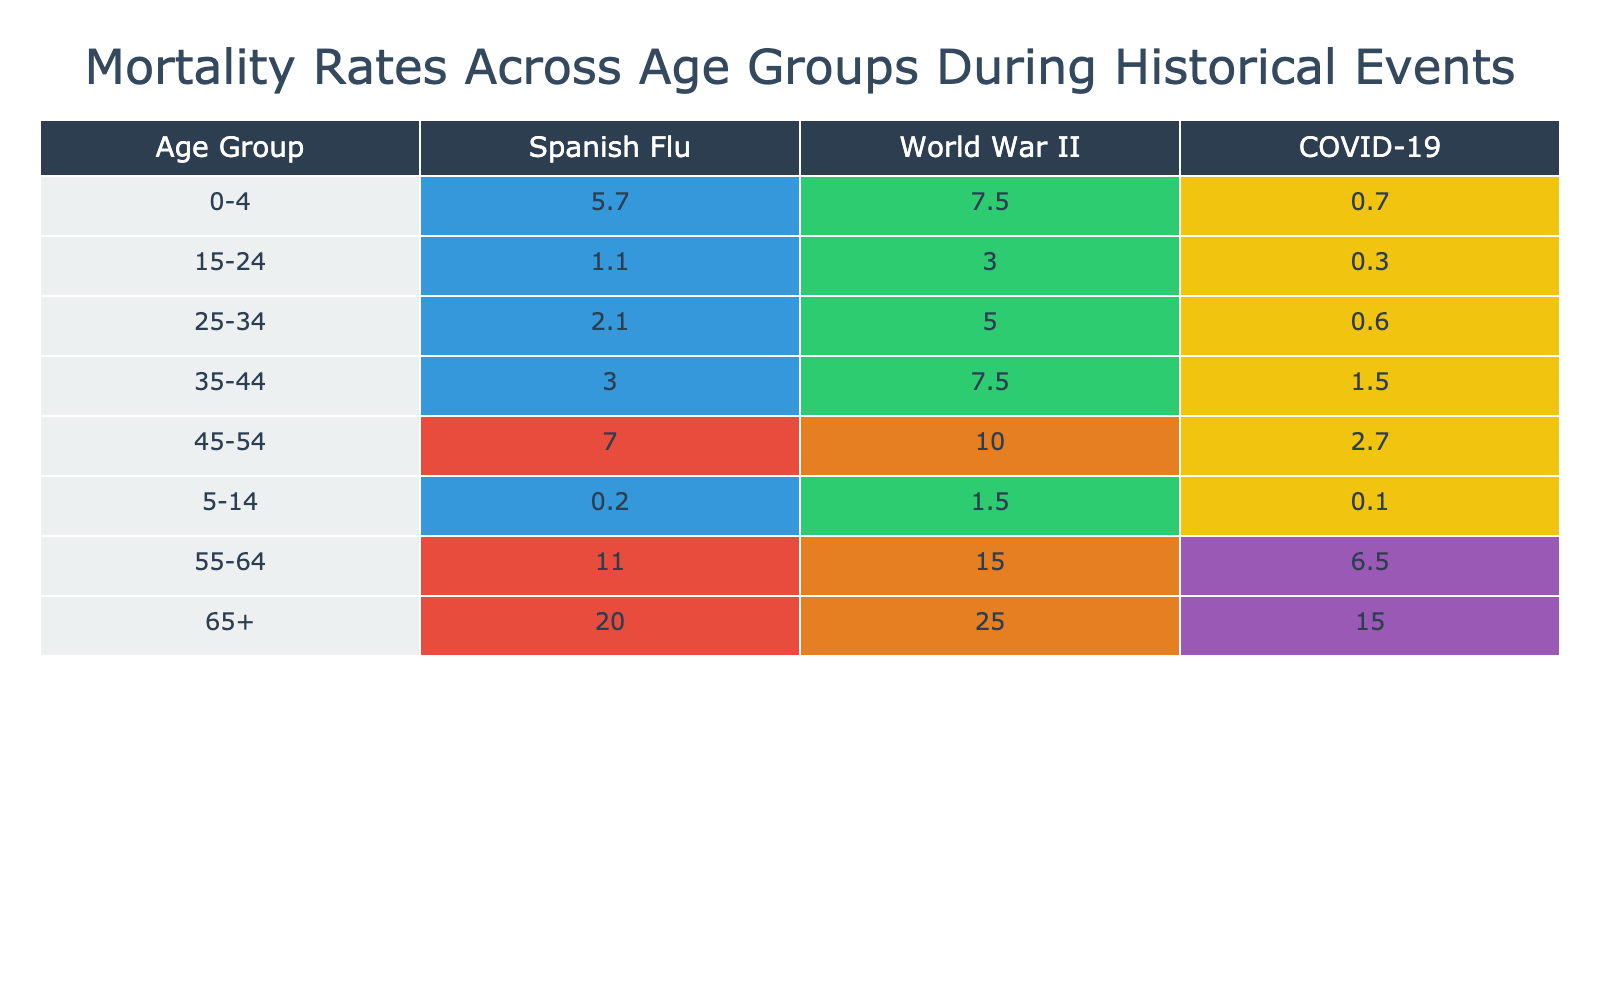What is the mortality rate for infants aged 0-4 during the Spanish Flu? According to the table, the mortality rate for the age group 0-4 during the event of the Spanish Flu in 1918 is listed as 5.7%.
Answer: 5.7% Which age group had the highest mortality rate during World War II? By examining the table, the age group 65+ during World War II (1939-1945) shows the highest mortality rate of 25.0%.
Answer: 65+ What is the difference in mortality rates between the age group 55-64 during the Spanish Flu and World War II? For the age group 55-64, the mortality rate during the Spanish Flu is 11.0% and during World War II, it is 15.0%. The difference is calculated as 15.0% - 11.0% = 4.0%.
Answer: 4.0% Was the mortality rate for children aged 5-14 higher during the Spanish Flu or World War II? The mortality rate for the age group 5-14 during the Spanish Flu is 0.2% and during World War II, it is 1.5%. Since 1.5% is greater than 0.2%, the mortality rate was higher during World War II.
Answer: Yes What is the average mortality rate for those aged 65+ across all three events? The mortality rates for the age group 65+ are 20.0% for the Spanish Flu, 25.0% for World War II, and 15.0% for COVID-19. To find the average, we sum these rates: 20.0% + 25.0% + 15.0% = 60.0% and divide by 3, yielding an average of 20.0%.
Answer: 20.0% 